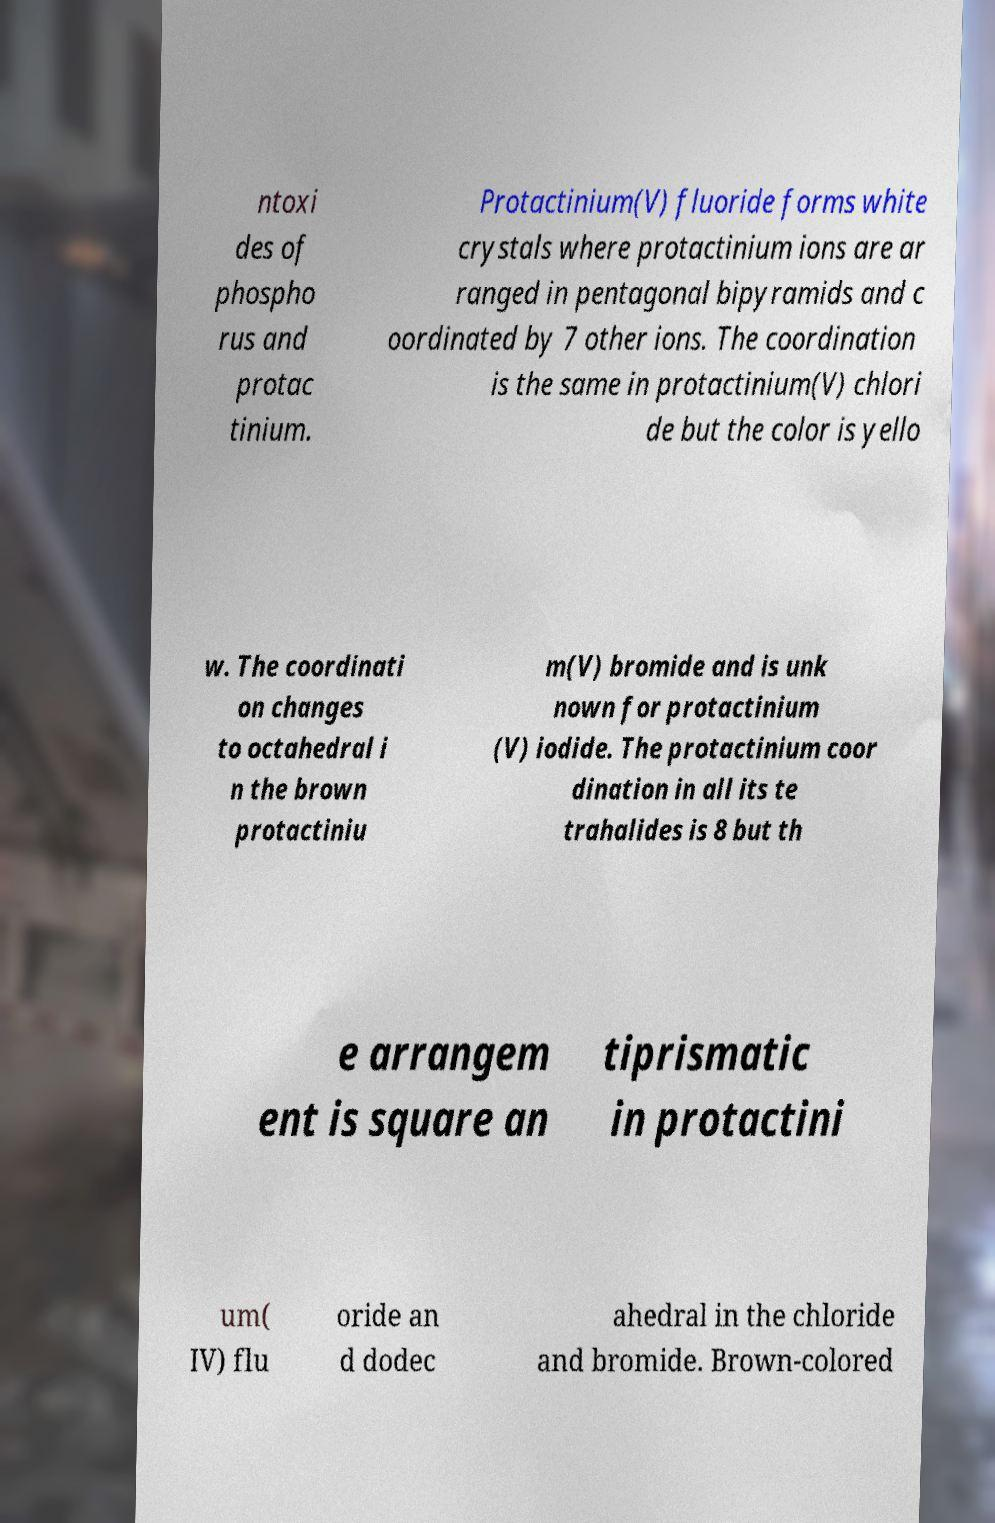Could you extract and type out the text from this image? ntoxi des of phospho rus and protac tinium. Protactinium(V) fluoride forms white crystals where protactinium ions are ar ranged in pentagonal bipyramids and c oordinated by 7 other ions. The coordination is the same in protactinium(V) chlori de but the color is yello w. The coordinati on changes to octahedral i n the brown protactiniu m(V) bromide and is unk nown for protactinium (V) iodide. The protactinium coor dination in all its te trahalides is 8 but th e arrangem ent is square an tiprismatic in protactini um( IV) flu oride an d dodec ahedral in the chloride and bromide. Brown-colored 